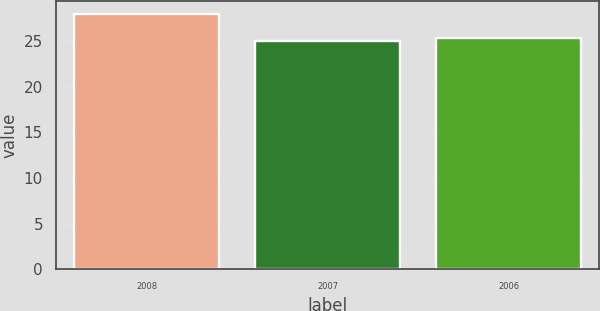Convert chart to OTSL. <chart><loc_0><loc_0><loc_500><loc_500><bar_chart><fcel>2008<fcel>2007<fcel>2006<nl><fcel>28<fcel>25<fcel>25.3<nl></chart> 